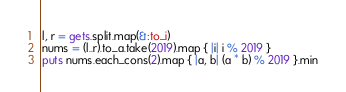Convert code to text. <code><loc_0><loc_0><loc_500><loc_500><_Ruby_>l, r = gets.split.map(&:to_i)
nums = (l..r).to_a.take(2019).map { |i| i % 2019 }
puts nums.each_cons(2).map { |a, b| (a * b) % 2019 }.min</code> 